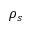Convert formula to latex. <formula><loc_0><loc_0><loc_500><loc_500>\rho _ { s }</formula> 